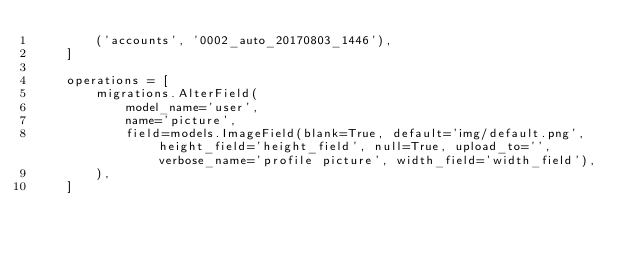<code> <loc_0><loc_0><loc_500><loc_500><_Python_>        ('accounts', '0002_auto_20170803_1446'),
    ]

    operations = [
        migrations.AlterField(
            model_name='user',
            name='picture',
            field=models.ImageField(blank=True, default='img/default.png', height_field='height_field', null=True, upload_to='', verbose_name='profile picture', width_field='width_field'),
        ),
    ]
</code> 